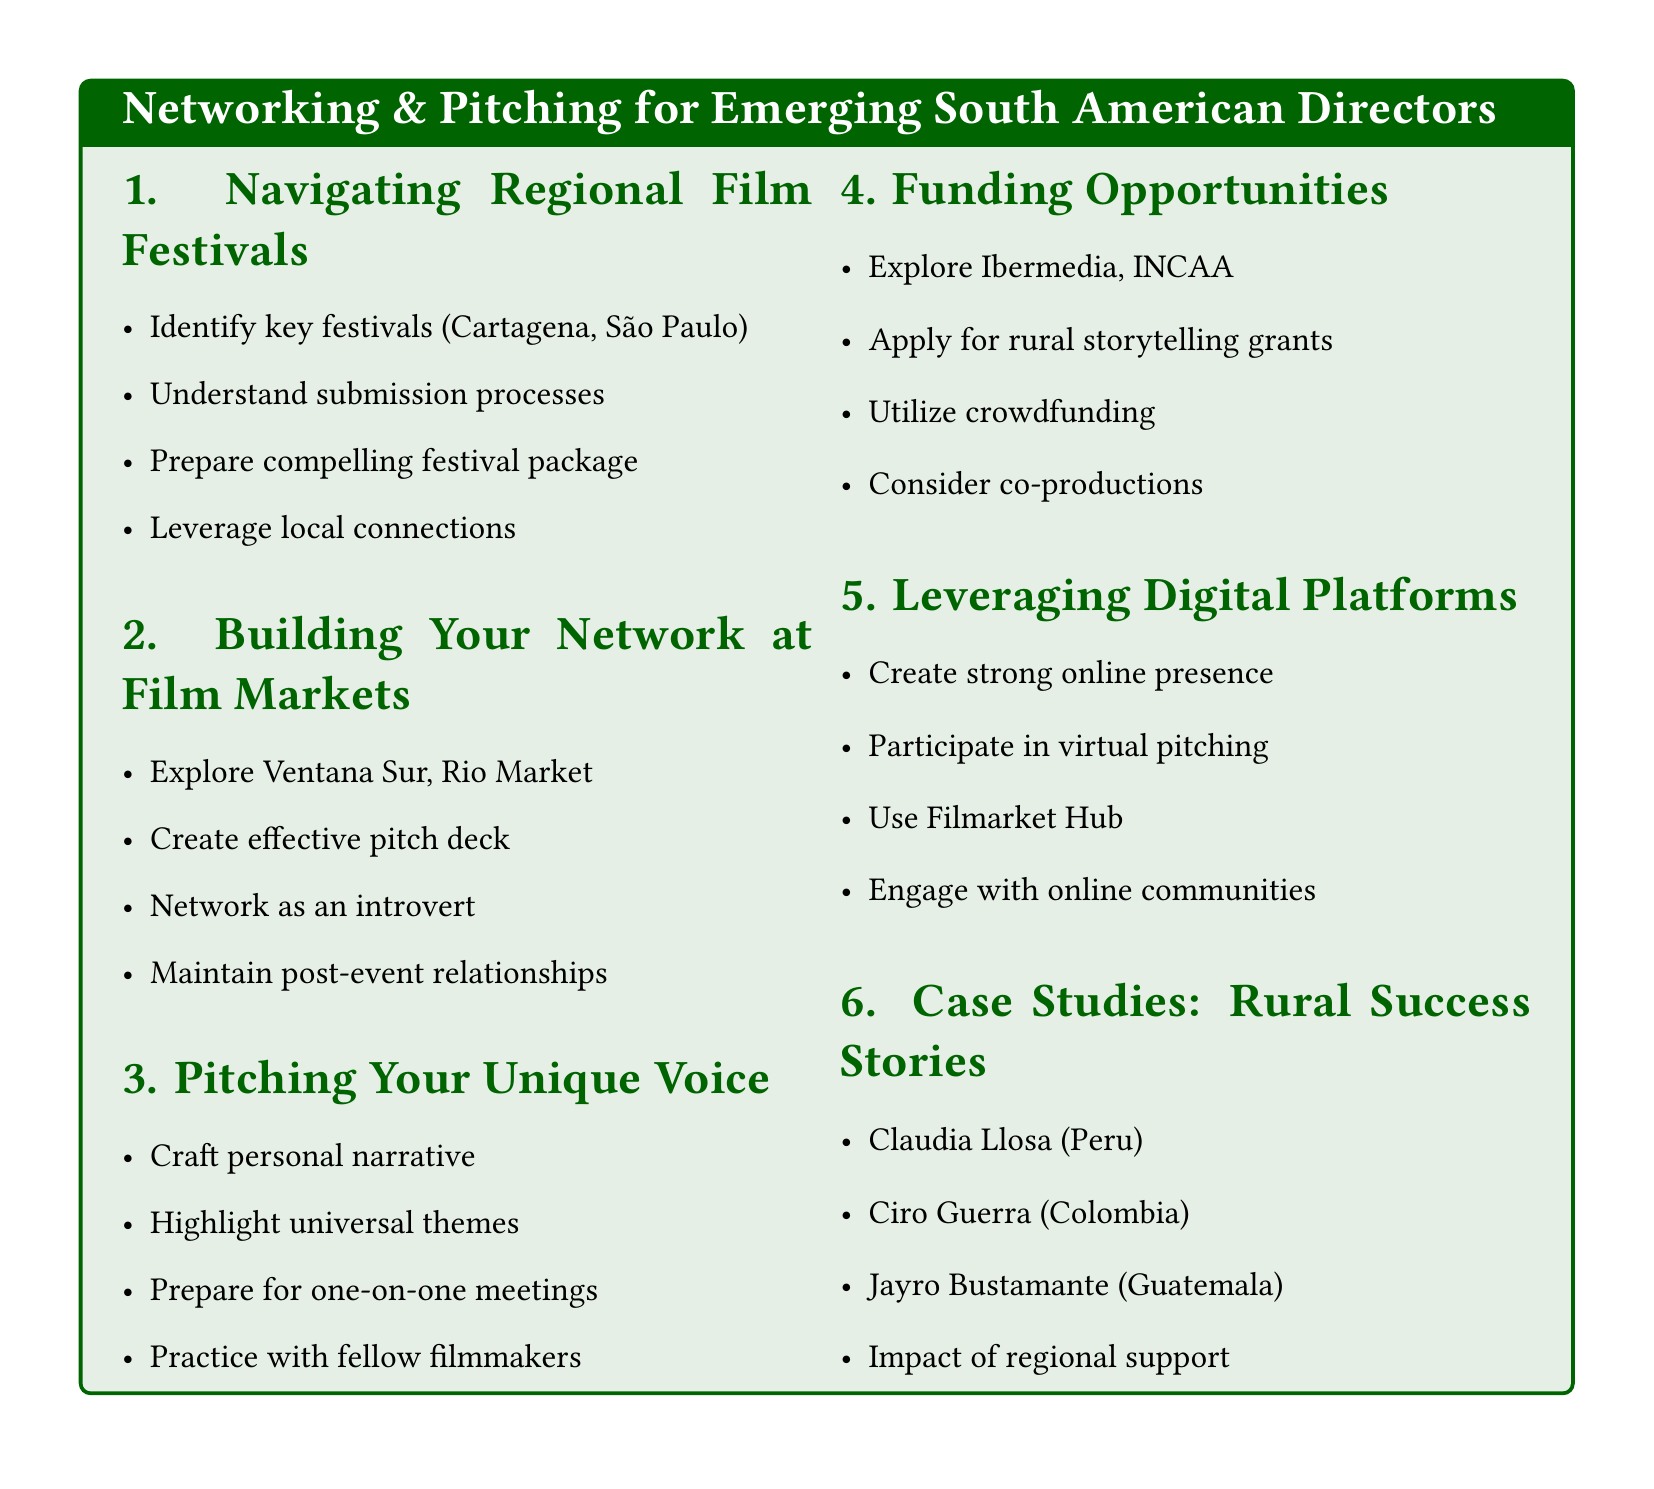what are two key festivals mentioned in the document? The document highlights two key festivals in South America: Cartagena International Film Festival and São Paulo International Film Festival.
Answer: Cartagena International Film Festival, São Paulo International Film Festival what is one major Latin American film market listed? The document lists Ventana Sur as one of the major Latin American film markets.
Answer: Ventana Sur what is the purpose of creating an effective pitch deck? An effective pitch deck aims to present community-focused stories compellingly to potential investors or collaborators.
Answer: To present community-focused stories compellingly which South American director is highlighted for analyzing success stories? Claudia Llosa is one of the South American directors highlighted for her success story in the document.
Answer: Claudia Llosa what is a crowdfunding strategy mentioned in the document? The document suggests utilizing crowdfunding strategies for community-based projects.
Answer: Utilizing crowdfunding strategies for community-based projects how many agenda items are listed in the document? The document contains six agenda items that cover different aspects of networking and pitching.
Answer: Six 